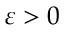<formula> <loc_0><loc_0><loc_500><loc_500>\varepsilon > 0</formula> 